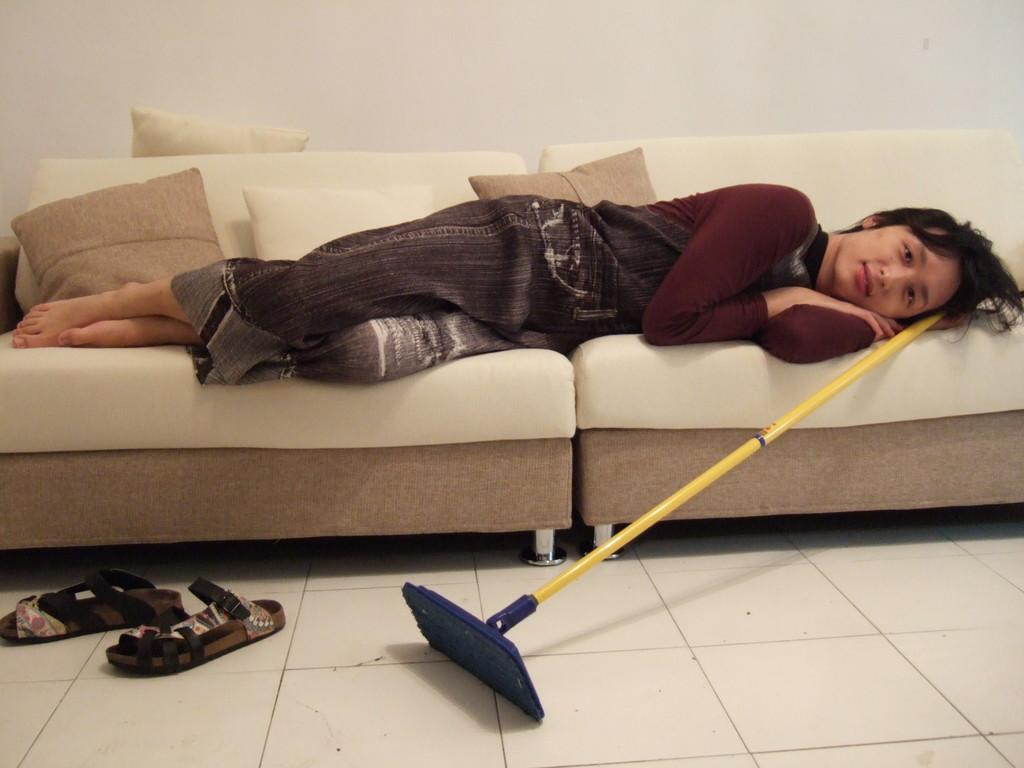What is the person in the image doing? There is a person lying on a couch in the image. What can be seen on the floor near the couch? There is footwear and an object on the floor. What is covering the couch? The couch has cushions on it. What type of respect can be seen in the image? There is no indication of respect in the image; it simply shows a person lying on a couch with footwear and an object on the floor. Can you see a snake in the image? There is no snake present in the image. 